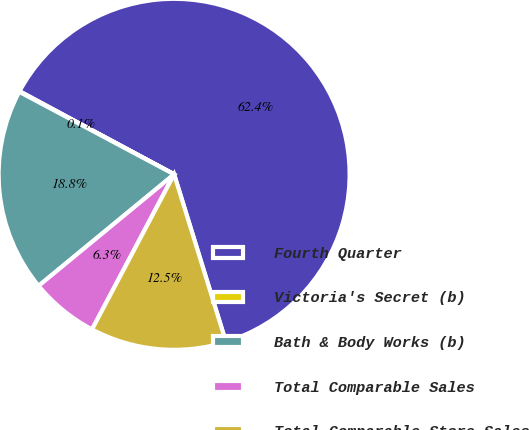Convert chart. <chart><loc_0><loc_0><loc_500><loc_500><pie_chart><fcel>Fourth Quarter<fcel>Victoria's Secret (b)<fcel>Bath & Body Works (b)<fcel>Total Comparable Sales<fcel>Total Comparable Store Sales<nl><fcel>62.37%<fcel>0.06%<fcel>18.75%<fcel>6.29%<fcel>12.52%<nl></chart> 